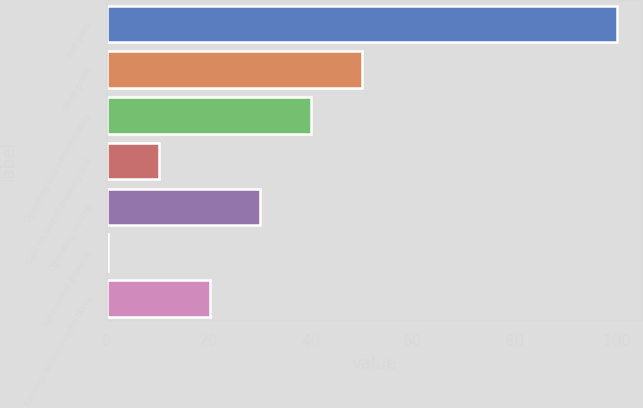<chart> <loc_0><loc_0><loc_500><loc_500><bar_chart><fcel>Net sales<fcel>Gross profit<fcel>Operating and administrative<fcel>Gain on sale of property and<fcel>Operating income<fcel>Net interest expense<fcel>Earnings before income taxes<nl><fcel>100<fcel>50.1<fcel>40.12<fcel>10.18<fcel>30.14<fcel>0.2<fcel>20.16<nl></chart> 